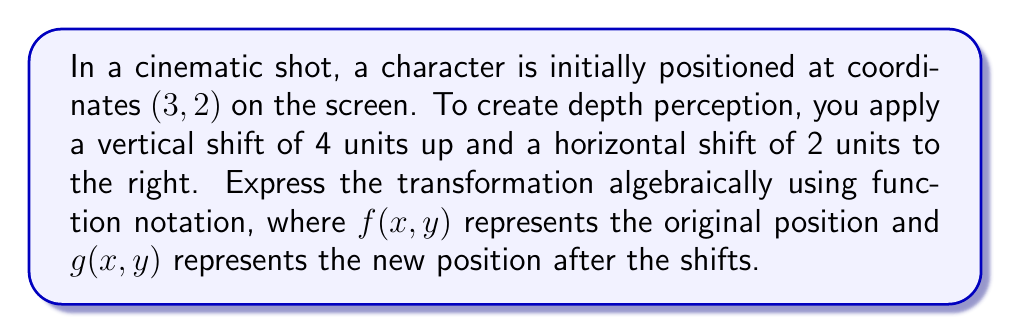Help me with this question. To solve this problem, we need to understand how vertical and horizontal shifts affect the position of a point in a coordinate system. Let's break it down step-by-step:

1) The original position is given by the function $f(x, y) = (x, y)$.

2) A vertical shift of 4 units up is represented by adding 4 to the y-coordinate:
   $(x, y + 4)$

3) A horizontal shift of 2 units to the right is represented by adding 2 to the x-coordinate:
   $(x + 2, y)$

4) Combining both shifts, we get:
   $g(x, y) = (x + 2, y + 4)$

5) To express this as a transformation of $f(x, y)$, we can write:
   $g(x, y) = f(x + 2, y + 4)$

This notation indicates that to get the new position, we first apply the shifts to the input of $f$, then evaluate the function.

6) To verify, let's apply this to the initial position (3, 2):
   $g(3, 2) = f(3 + 2, 2 + 4) = f(5, 6) = (5, 6)$

   This correctly gives us the new position after the shifts.
Answer: $g(x, y) = f(x + 2, y + 4)$ 